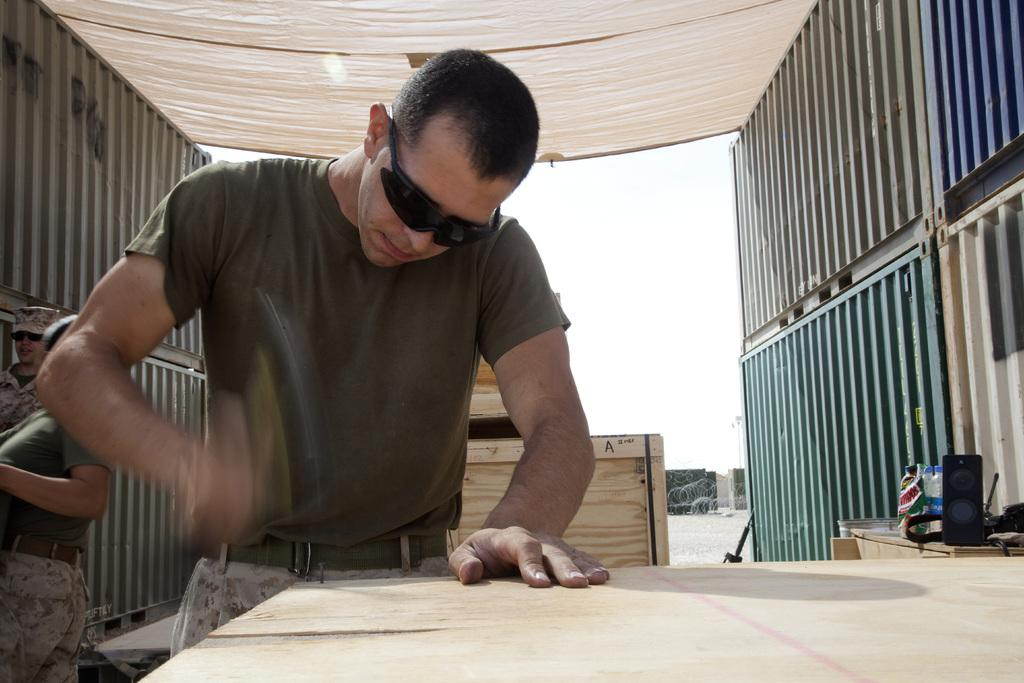What is the man in the image wearing on his face? The man is wearing goggles in the image. What tool is the man holding in the image? The man is holding a hammer in the image. What is the man trying to do with the hammer? The man appears to be trying to hit a nail in the image. How many people are on the left side of the image? There are two people on the left side of the image. Where is the speaker located in the image? The speaker is on the right side of the image. On what is the speaker placed in the image? The speaker is on a table in the image. What is the size of the impulse that the man is trying to hit with the hammer? There is no mention of an impulse in the image, and the size of an impulse cannot be determined visually. 